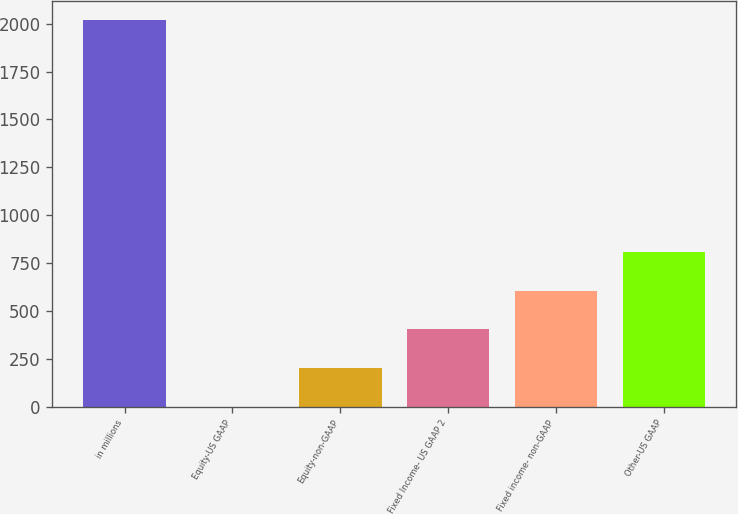Convert chart to OTSL. <chart><loc_0><loc_0><loc_500><loc_500><bar_chart><fcel>in millions<fcel>Equity-US GAAP<fcel>Equity-non-GAAP<fcel>Fixed Income- US GAAP 2<fcel>Fixed income- non-GAAP<fcel>Other-US GAAP<nl><fcel>2017<fcel>1<fcel>202.6<fcel>404.2<fcel>605.8<fcel>807.4<nl></chart> 